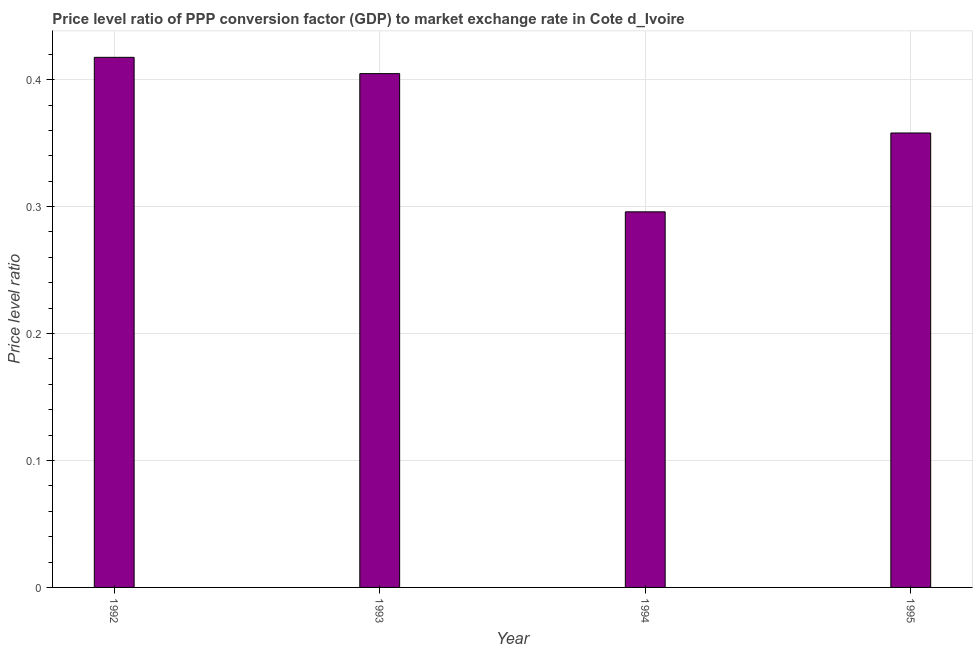Does the graph contain any zero values?
Your response must be concise. No. Does the graph contain grids?
Your answer should be very brief. Yes. What is the title of the graph?
Offer a terse response. Price level ratio of PPP conversion factor (GDP) to market exchange rate in Cote d_Ivoire. What is the label or title of the Y-axis?
Your response must be concise. Price level ratio. What is the price level ratio in 1992?
Offer a terse response. 0.42. Across all years, what is the maximum price level ratio?
Your response must be concise. 0.42. Across all years, what is the minimum price level ratio?
Your response must be concise. 0.3. What is the sum of the price level ratio?
Provide a short and direct response. 1.48. What is the difference between the price level ratio in 1992 and 1994?
Provide a succinct answer. 0.12. What is the average price level ratio per year?
Ensure brevity in your answer.  0.37. What is the median price level ratio?
Give a very brief answer. 0.38. What is the ratio of the price level ratio in 1993 to that in 1994?
Your response must be concise. 1.37. Is the price level ratio in 1992 less than that in 1994?
Your response must be concise. No. Is the difference between the price level ratio in 1992 and 1995 greater than the difference between any two years?
Make the answer very short. No. What is the difference between the highest and the second highest price level ratio?
Your answer should be very brief. 0.01. What is the difference between the highest and the lowest price level ratio?
Your answer should be very brief. 0.12. Are all the bars in the graph horizontal?
Your answer should be compact. No. What is the difference between two consecutive major ticks on the Y-axis?
Provide a short and direct response. 0.1. What is the Price level ratio in 1992?
Keep it short and to the point. 0.42. What is the Price level ratio in 1993?
Your response must be concise. 0.4. What is the Price level ratio in 1994?
Offer a terse response. 0.3. What is the Price level ratio in 1995?
Keep it short and to the point. 0.36. What is the difference between the Price level ratio in 1992 and 1993?
Your answer should be compact. 0.01. What is the difference between the Price level ratio in 1992 and 1994?
Your response must be concise. 0.12. What is the difference between the Price level ratio in 1992 and 1995?
Your response must be concise. 0.06. What is the difference between the Price level ratio in 1993 and 1994?
Offer a terse response. 0.11. What is the difference between the Price level ratio in 1993 and 1995?
Provide a short and direct response. 0.05. What is the difference between the Price level ratio in 1994 and 1995?
Provide a short and direct response. -0.06. What is the ratio of the Price level ratio in 1992 to that in 1993?
Provide a short and direct response. 1.03. What is the ratio of the Price level ratio in 1992 to that in 1994?
Offer a very short reply. 1.41. What is the ratio of the Price level ratio in 1992 to that in 1995?
Your answer should be compact. 1.17. What is the ratio of the Price level ratio in 1993 to that in 1994?
Provide a succinct answer. 1.37. What is the ratio of the Price level ratio in 1993 to that in 1995?
Provide a short and direct response. 1.13. What is the ratio of the Price level ratio in 1994 to that in 1995?
Your answer should be very brief. 0.83. 